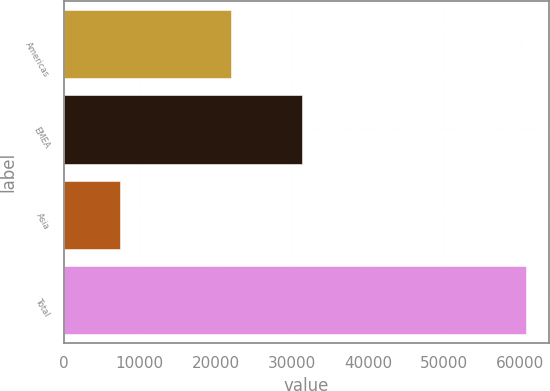Convert chart. <chart><loc_0><loc_0><loc_500><loc_500><bar_chart><fcel>Americas<fcel>EMEA<fcel>Asia<fcel>Total<nl><fcel>22032<fcel>31295<fcel>7410<fcel>60737<nl></chart> 